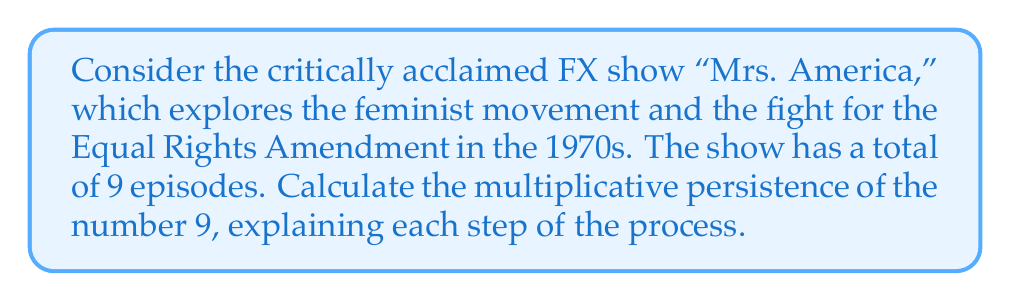Show me your answer to this math problem. Multiplicative persistence is the number of steps required to reduce a number to a single digit through repeated multiplication of its digits. Let's calculate this for the number 9:

Step 1: Start with the number 9.
$9$ is already a single digit, so no multiplication is needed.

Therefore, the multiplicative persistence of 9 is 0.

To illustrate why this is interesting in the context of number theory:
1. Most numbers have a multiplicative persistence greater than 0.
2. Single-digit numbers always have a multiplicative persistence of 0.
3. The concept connects to the show's themes by demonstrating how even small numbers (like the 9 episodes) can represent significant ideas (the complexity of the feminist movement).

Note: If the show had 27 episodes, for example, the calculation would be:
$27 \rightarrow 2 \times 7 = 14 \rightarrow 1 \times 4 = 4$
This would have a multiplicative persistence of 2.
Answer: 0 